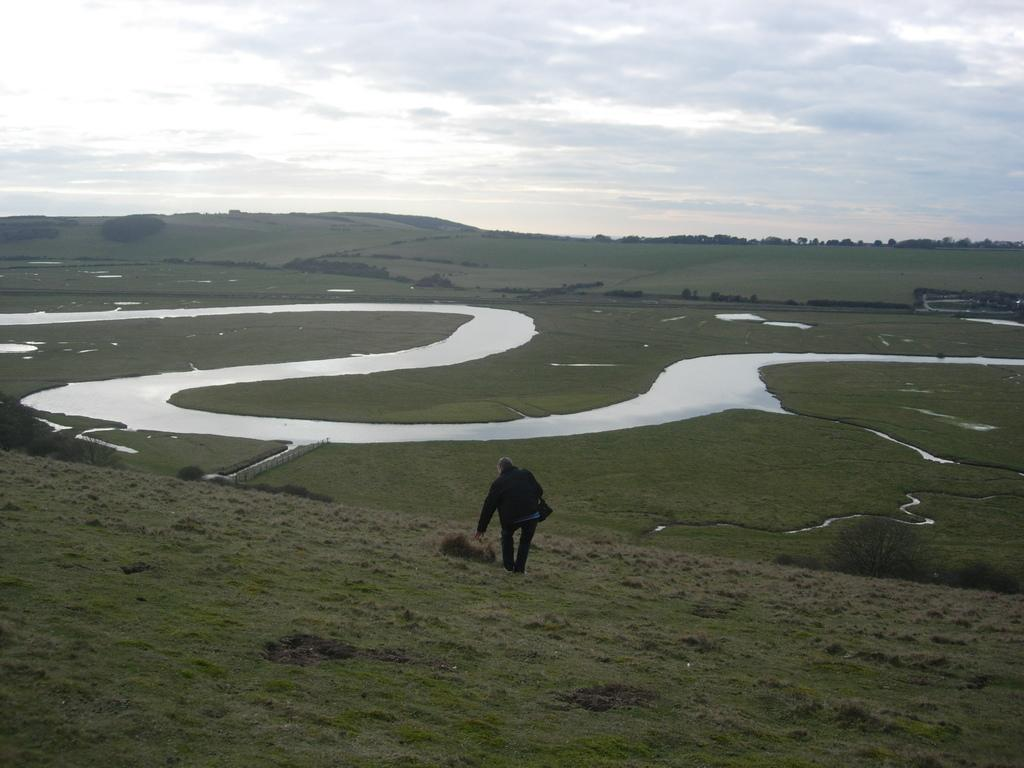Who or what is the main subject in the middle of the image? There is a person in the middle of the image. What can be seen in the background of the image? Water, trees, and clouds are visible in the background of the image. How does the person lift the cloud in the image? The person does not lift the cloud in the image; there is no interaction between the person and the cloud. 